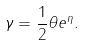Convert formula to latex. <formula><loc_0><loc_0><loc_500><loc_500>\gamma = \frac { 1 } { 2 } \theta e ^ { \eta } .</formula> 